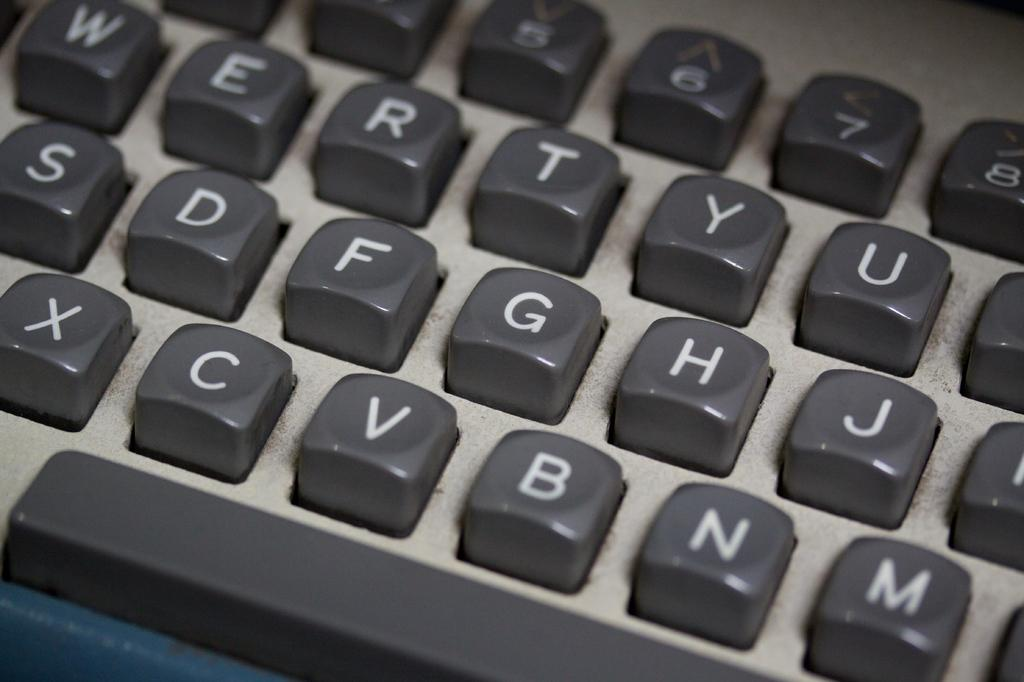Provide a one-sentence caption for the provided image. A grey keyboard with white letters on the keys that include X, C, V, B, and N on the bottom row. 